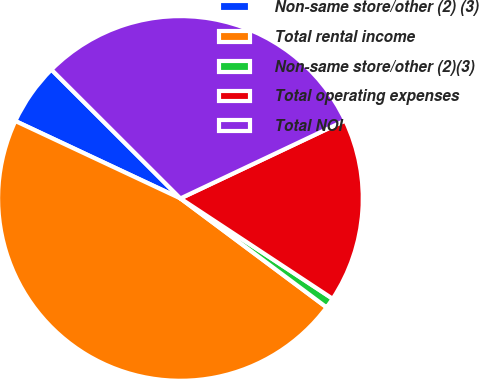<chart> <loc_0><loc_0><loc_500><loc_500><pie_chart><fcel>Non-same store/other (2) (3)<fcel>Total rental income<fcel>Non-same store/other (2)(3)<fcel>Total operating expenses<fcel>Total NOI<nl><fcel>5.51%<fcel>46.79%<fcel>0.92%<fcel>16.31%<fcel>30.48%<nl></chart> 